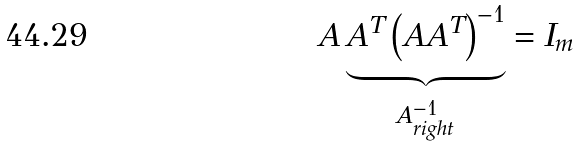Convert formula to latex. <formula><loc_0><loc_0><loc_500><loc_500>A \underbrace { A ^ { T } \left ( A A ^ { T } \right ) ^ { - 1 } } _ { A _ { r i g h t } ^ { - 1 } } = I _ { m }</formula> 